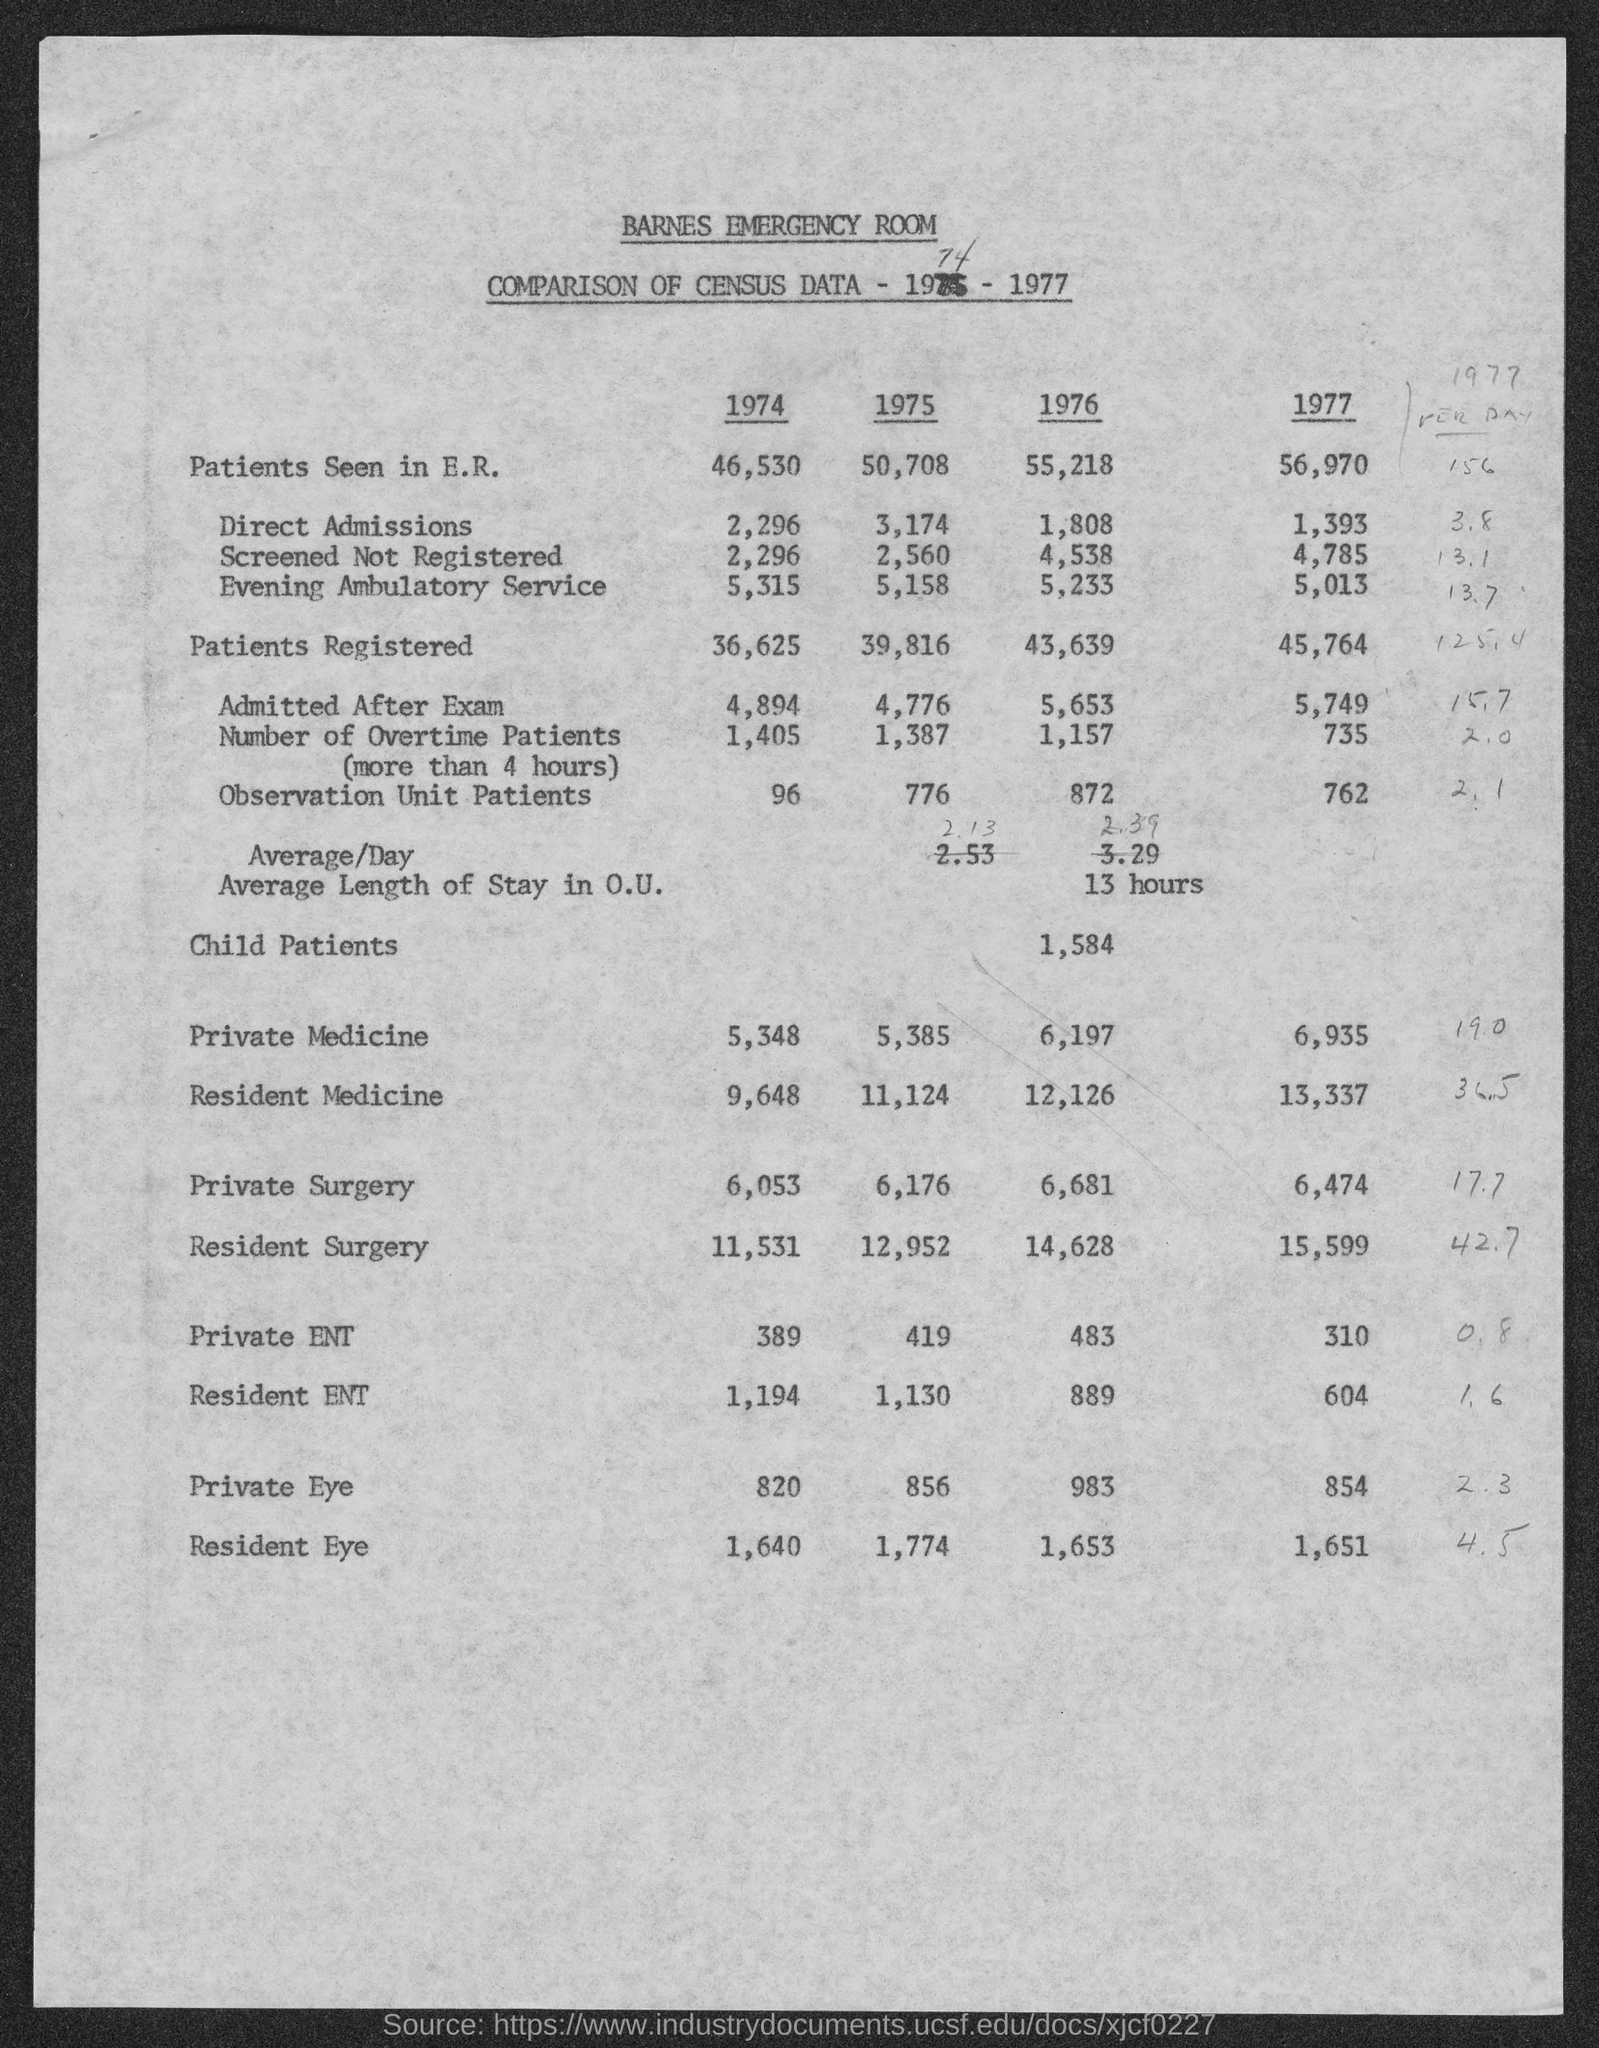Outline some significant characteristics in this image. In 1975, a total of 3,174 students were admitted directly to the university. The number of patients registered was higher in 1977 than in any other year. In 1974, there were 1,405 patients who required overtime. The first title in the document is "Barnes Emergency Room. The number of patients in the observation unit was higher in 1976 compared to other years. 